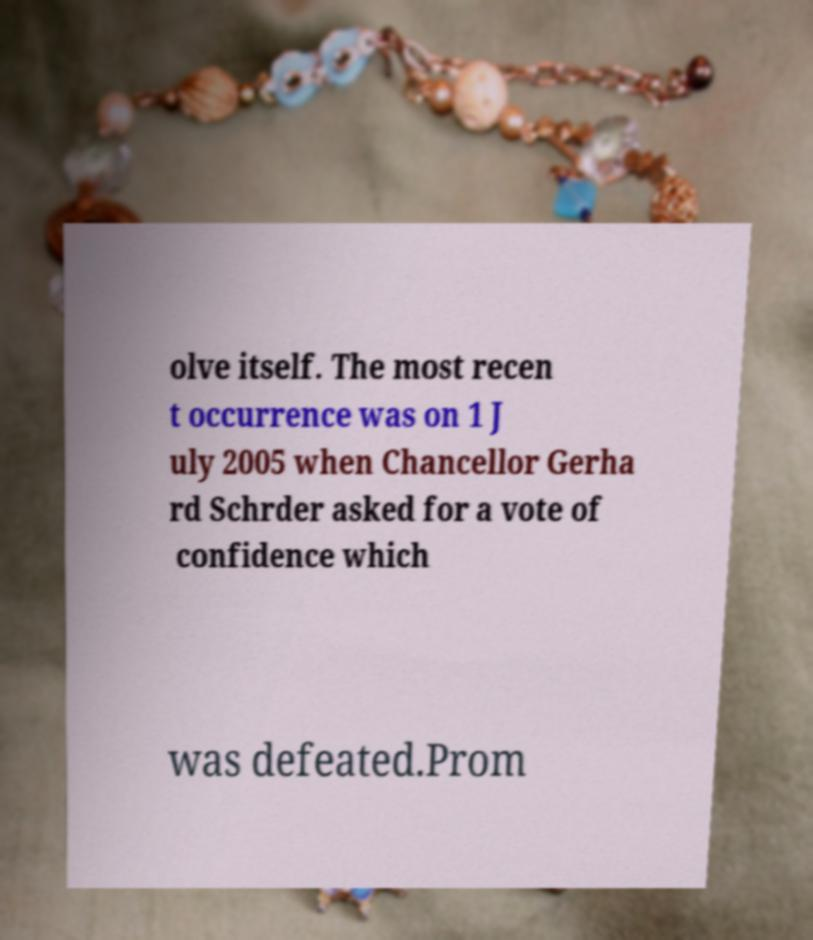Can you accurately transcribe the text from the provided image for me? olve itself. The most recen t occurrence was on 1 J uly 2005 when Chancellor Gerha rd Schrder asked for a vote of confidence which was defeated.Prom 